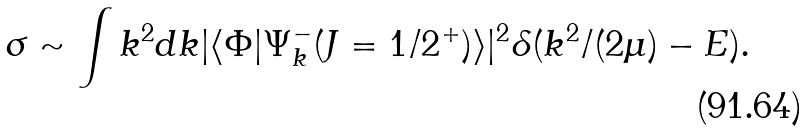<formula> <loc_0><loc_0><loc_500><loc_500>\sigma \sim \int k ^ { 2 } d k | \langle \Phi | \Psi _ { k } ^ { - } ( J = 1 / 2 ^ { + } ) \rangle | ^ { 2 } \delta ( k ^ { 2 } / ( 2 \mu ) - E ) .</formula> 